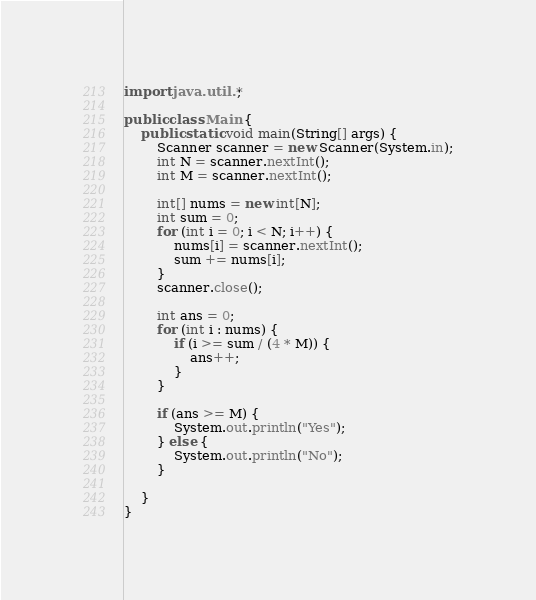Convert code to text. <code><loc_0><loc_0><loc_500><loc_500><_Java_>import java.util.*;

public class Main {
    public static void main(String[] args) {
        Scanner scanner = new Scanner(System.in);
        int N = scanner.nextInt();
        int M = scanner.nextInt();

        int[] nums = new int[N];
        int sum = 0;
        for (int i = 0; i < N; i++) {
            nums[i] = scanner.nextInt();
            sum += nums[i];
        }
        scanner.close();

        int ans = 0;
        for (int i : nums) {
            if (i >= sum / (4 * M)) {
                ans++;
            }
        }

        if (ans >= M) {
            System.out.println("Yes");
        } else {
            System.out.println("No");
        }

    }
}
</code> 